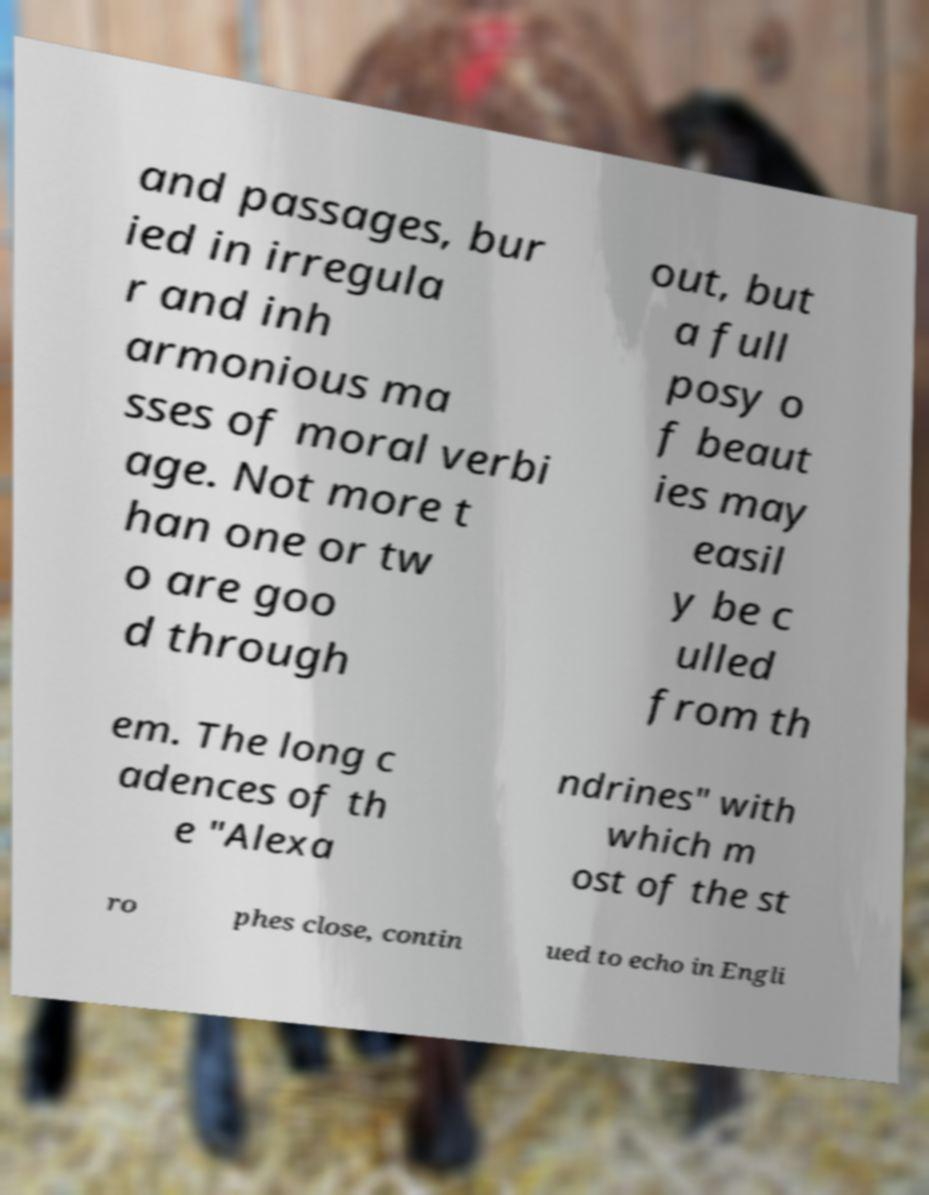Please read and relay the text visible in this image. What does it say? and passages, bur ied in irregula r and inh armonious ma sses of moral verbi age. Not more t han one or tw o are goo d through out, but a full posy o f beaut ies may easil y be c ulled from th em. The long c adences of th e "Alexa ndrines" with which m ost of the st ro phes close, contin ued to echo in Engli 